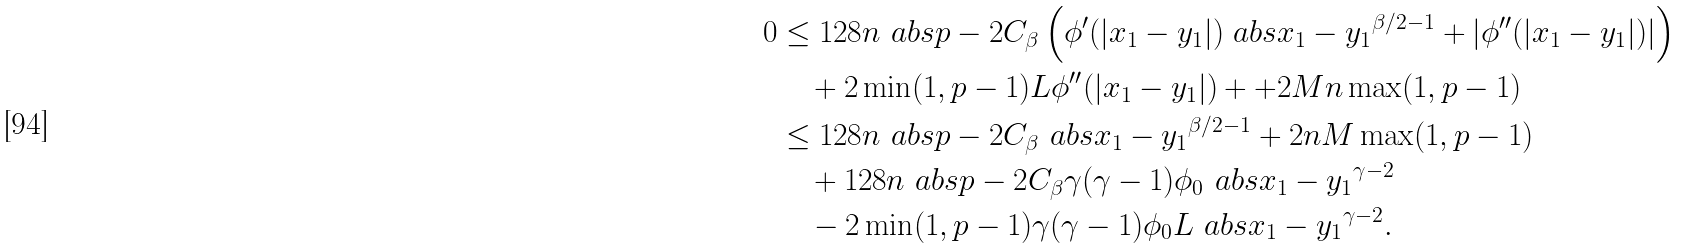Convert formula to latex. <formula><loc_0><loc_0><loc_500><loc_500>0 & \leq 1 2 8 n \ a b s { p - 2 } C _ { \beta } \left ( \phi ^ { \prime } ( | x _ { 1 } - y _ { 1 } | ) \ a b s { x _ { 1 } - y _ { 1 } } ^ { \beta / 2 - 1 } + | \phi ^ { \prime \prime } ( | x _ { 1 } - y _ { 1 } | ) | \right ) \\ & \quad + 2 \min ( 1 , p - 1 ) L \phi ^ { \prime \prime } ( | x _ { 1 } - y _ { 1 } | ) + + 2 M n \max ( 1 , p - 1 ) \\ & \leq 1 2 8 n \ a b s { p - 2 } C _ { \beta } \ a b s { x _ { 1 } - y _ { 1 } } ^ { \beta / 2 - 1 } + 2 n M \max ( 1 , p - 1 ) \\ & \quad + 1 2 8 n \ a b s { p - 2 } C _ { \beta } \gamma ( \gamma - 1 ) \phi _ { 0 } \ a b s { x _ { 1 } - y _ { 1 } } ^ { \gamma - 2 } \\ & \quad - 2 \min ( 1 , p - 1 ) \gamma ( \gamma - 1 ) \phi _ { 0 } L \ a b s { x _ { 1 } - y _ { 1 } } ^ { \gamma - 2 } .</formula> 